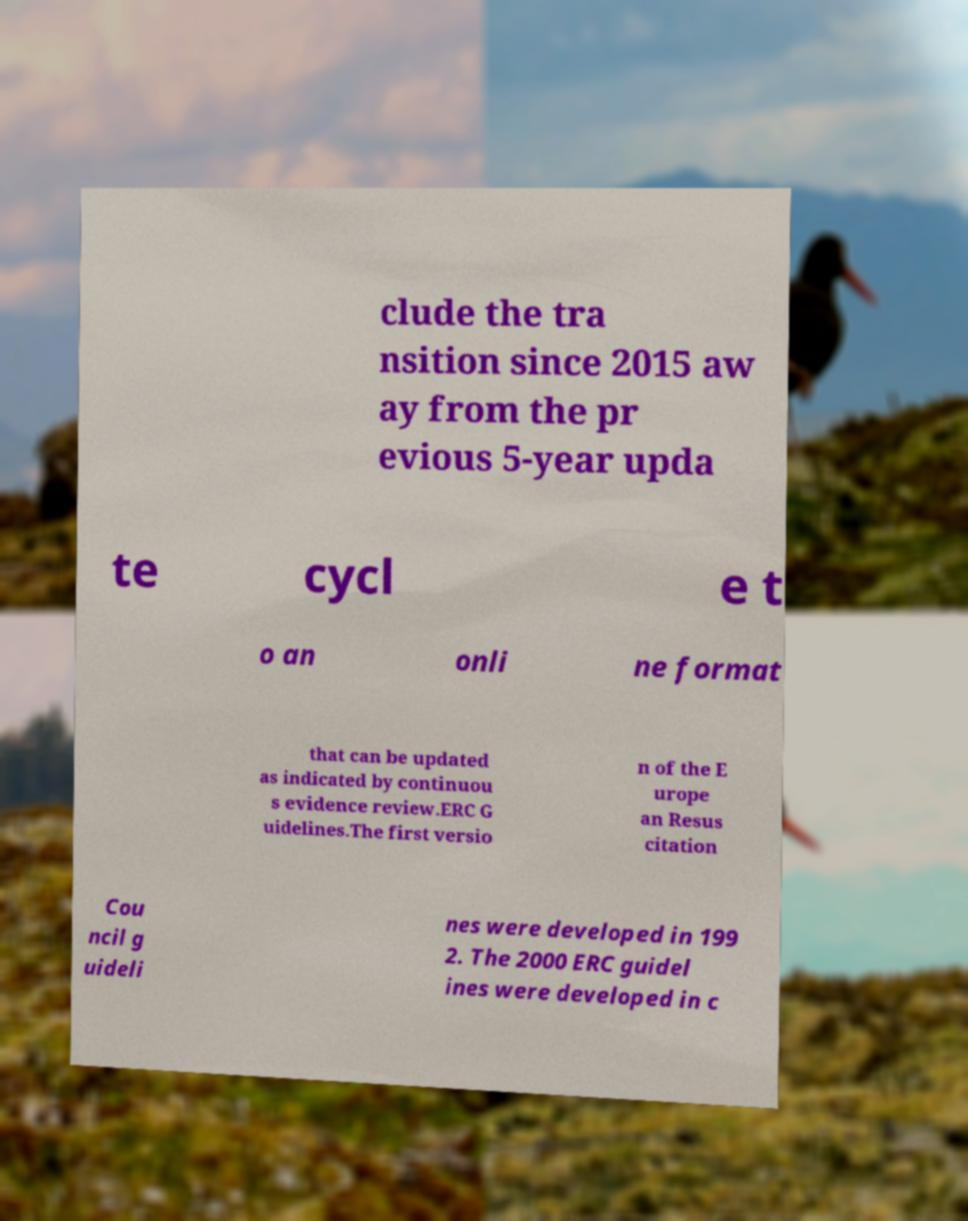Please read and relay the text visible in this image. What does it say? clude the tra nsition since 2015 aw ay from the pr evious 5-year upda te cycl e t o an onli ne format that can be updated as indicated by continuou s evidence review.ERC G uidelines.The first versio n of the E urope an Resus citation Cou ncil g uideli nes were developed in 199 2. The 2000 ERC guidel ines were developed in c 